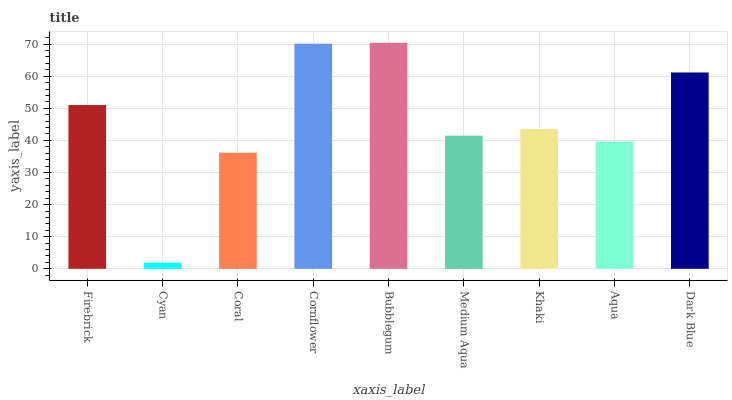Is Cyan the minimum?
Answer yes or no. Yes. Is Bubblegum the maximum?
Answer yes or no. Yes. Is Coral the minimum?
Answer yes or no. No. Is Coral the maximum?
Answer yes or no. No. Is Coral greater than Cyan?
Answer yes or no. Yes. Is Cyan less than Coral?
Answer yes or no. Yes. Is Cyan greater than Coral?
Answer yes or no. No. Is Coral less than Cyan?
Answer yes or no. No. Is Khaki the high median?
Answer yes or no. Yes. Is Khaki the low median?
Answer yes or no. Yes. Is Cornflower the high median?
Answer yes or no. No. Is Aqua the low median?
Answer yes or no. No. 